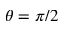<formula> <loc_0><loc_0><loc_500><loc_500>\theta = \pi / 2</formula> 